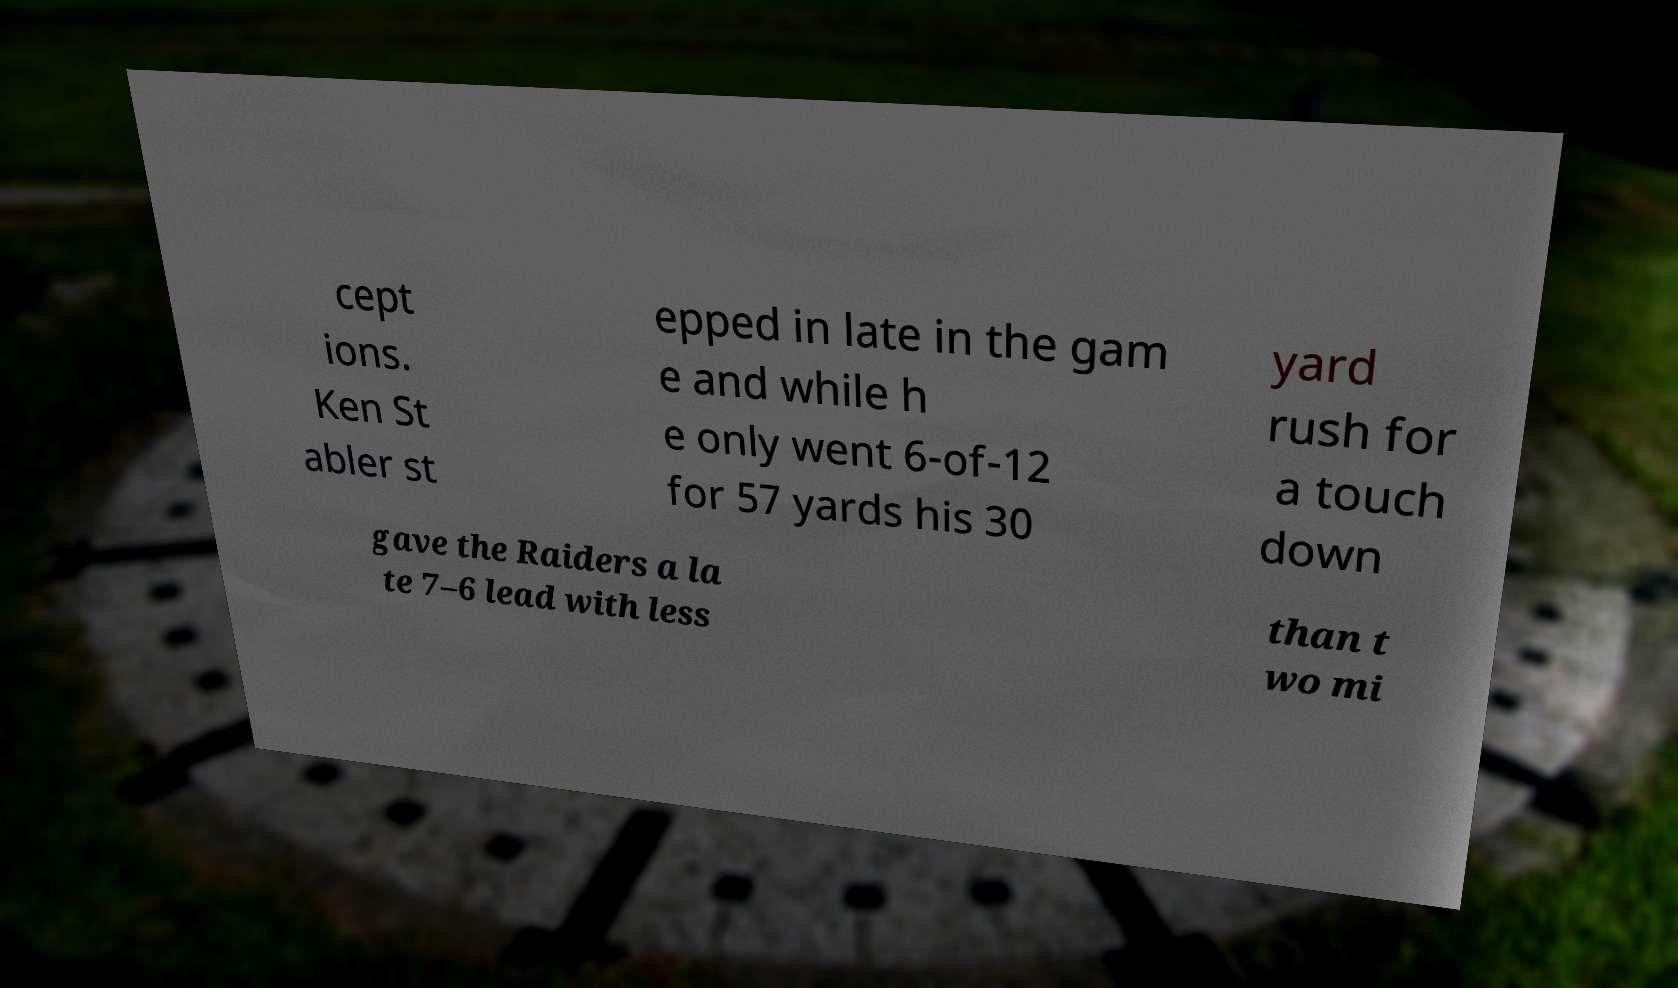Could you extract and type out the text from this image? cept ions. Ken St abler st epped in late in the gam e and while h e only went 6-of-12 for 57 yards his 30 yard rush for a touch down gave the Raiders a la te 7–6 lead with less than t wo mi 